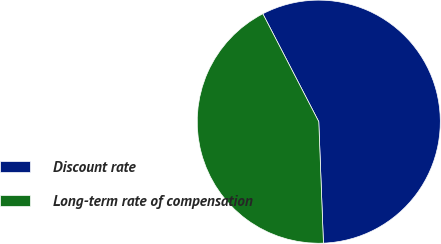<chart> <loc_0><loc_0><loc_500><loc_500><pie_chart><fcel>Discount rate<fcel>Long-term rate of compensation<nl><fcel>57.0%<fcel>43.0%<nl></chart> 